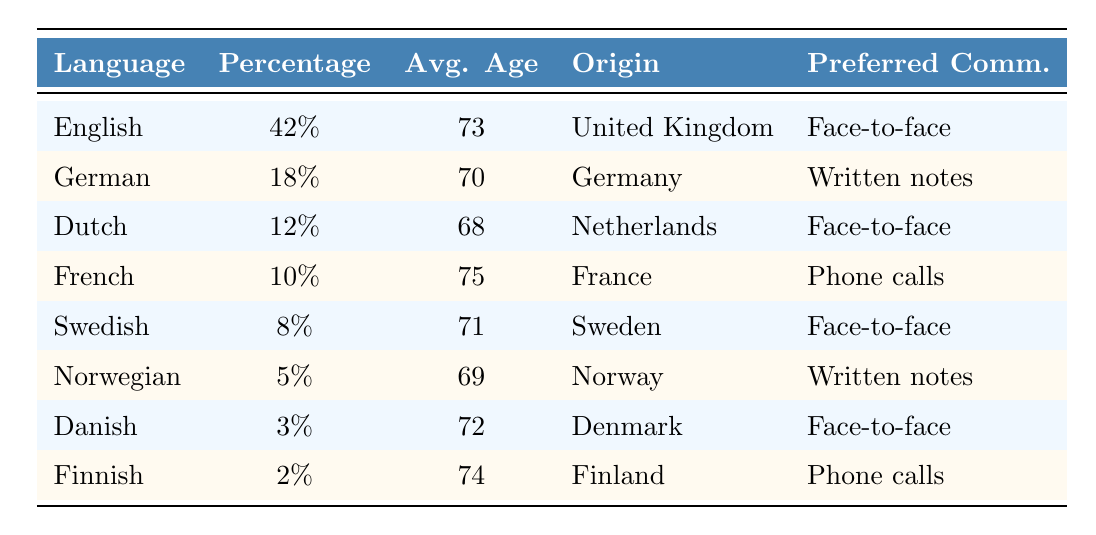What percentage of elderly expats are English speakers? The table shows that English is spoken by 42% of elderly expats.
Answer: 42% What is the average age of German-speaking elderly expats? The table lists the average age of German speakers as 70 years.
Answer: 70 Which language has the highest percentage of expats? The highest percentage in the table is for English, at 42%.
Answer: English Is the preferred communication method for Finnish expats via phone calls? The table indicates that Finnish speakers prefer phone calls, which confirms the statement.
Answer: Yes What is the most common country of origin for Dutch-speaking expats? According to the table, Dutch-speaking expats mainly come from the Netherlands.
Answer: Netherlands How many more percent of expats speak English than Finnish? The difference is calculated by subtracting the percentage of Finnish speakers (2%) from English speakers (42%), resulting in 40%.
Answer: 40% What is the average age of the three oldest groups based on the table? The ages for the three oldest groups (French, Finnish, and English) are 75, 74, and 73, respectively. Their average is (75 + 74 + 73) / 3 = 74.
Answer: 74 Which preferred communication method is common among Swedish and Dutch expats? Both Swedish and Dutch-speaking expats prefer face-to-face conversations for communication.
Answer: Face-to-face conversation What is the total percentage of expats who are Swedish and Danish speakers combined? The table shows Swedish speakers at 8% and Danish speakers at 3%. Adding them gives 8% + 3% = 11%.
Answer: 11% Is there any language in the table with a percentage lower than 5%? The lowest percentage in the table is for Finnish at 2%, which confirms that there is one language below 5%.
Answer: Yes What language has the oldest average age among the expats listed in the data? The oldest average age is 75, which belongs to French-speaking expats, according to the table.
Answer: French 